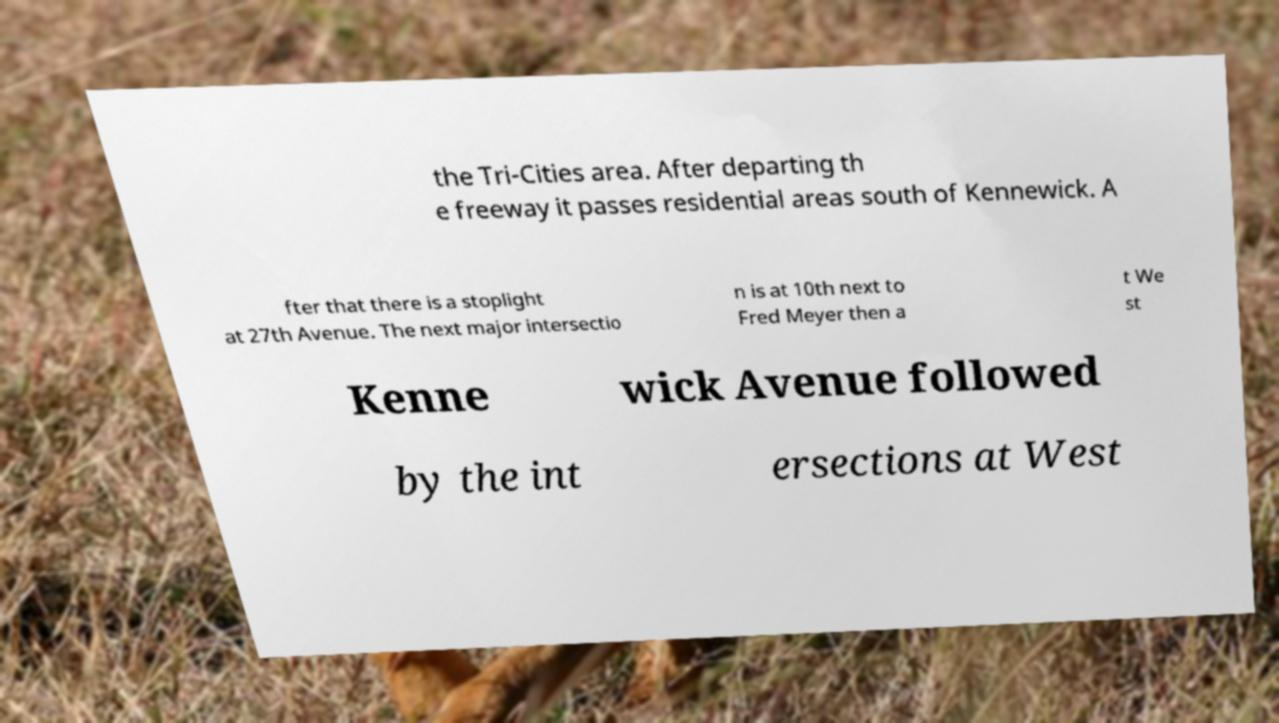Please read and relay the text visible in this image. What does it say? the Tri-Cities area. After departing th e freeway it passes residential areas south of Kennewick. A fter that there is a stoplight at 27th Avenue. The next major intersectio n is at 10th next to Fred Meyer then a t We st Kenne wick Avenue followed by the int ersections at West 